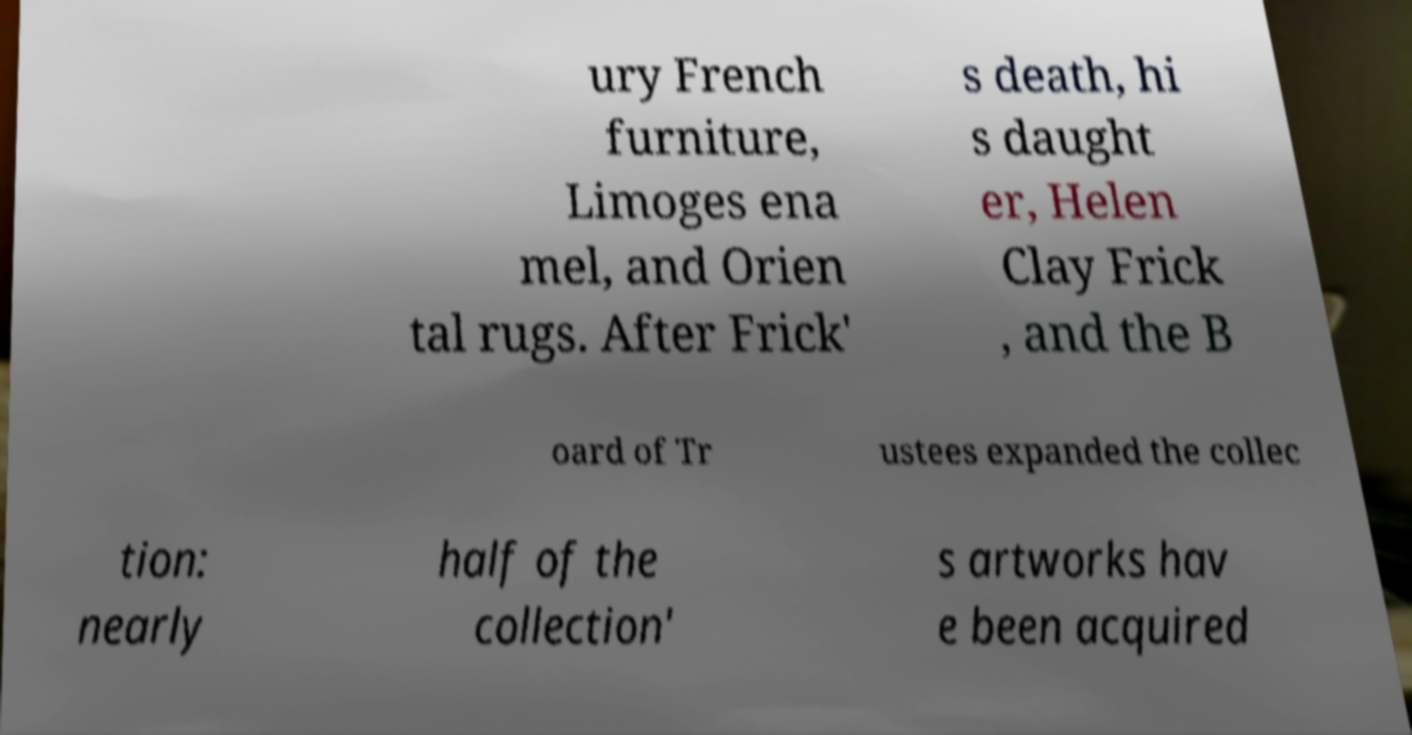Could you assist in decoding the text presented in this image and type it out clearly? ury French furniture, Limoges ena mel, and Orien tal rugs. After Frick' s death, hi s daught er, Helen Clay Frick , and the B oard of Tr ustees expanded the collec tion: nearly half of the collection' s artworks hav e been acquired 